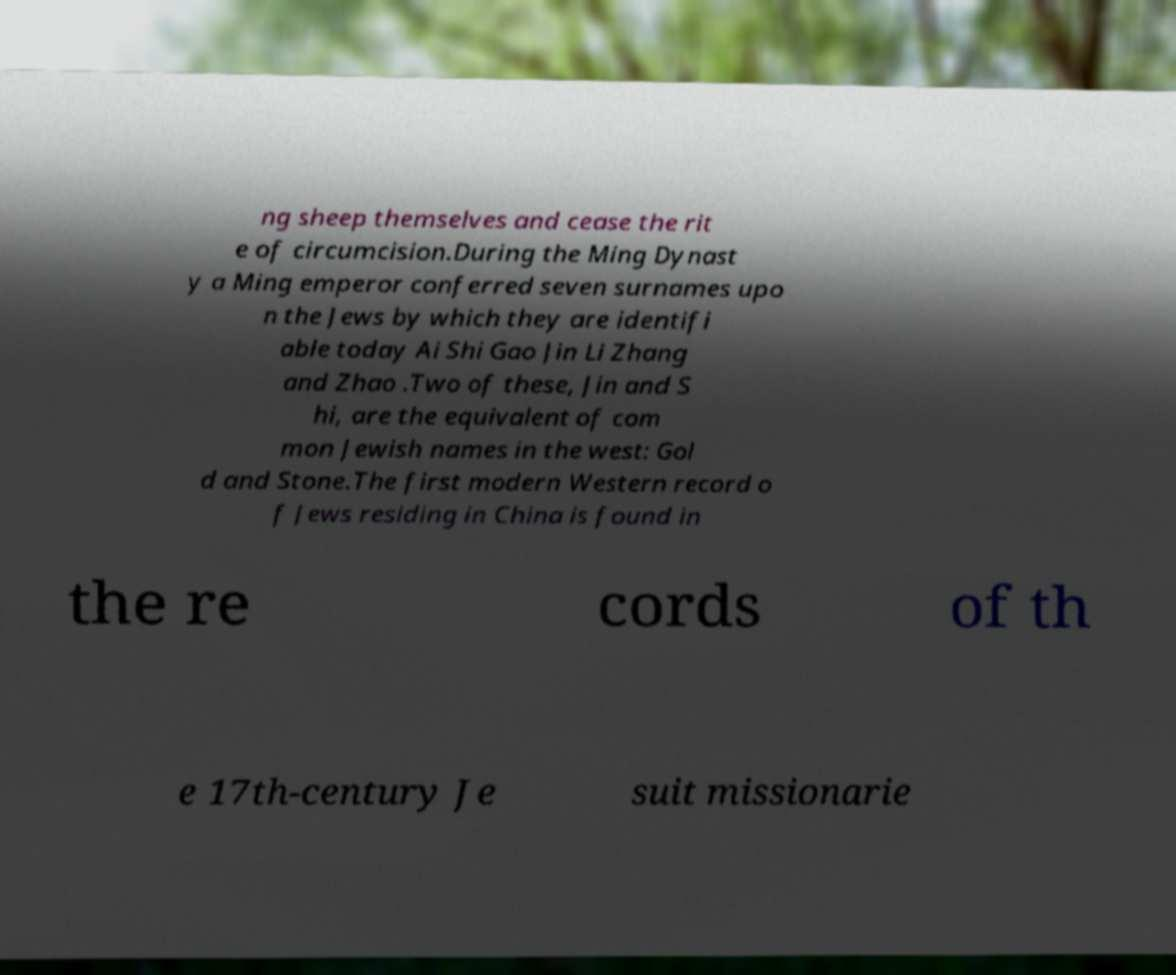There's text embedded in this image that I need extracted. Can you transcribe it verbatim? ng sheep themselves and cease the rit e of circumcision.During the Ming Dynast y a Ming emperor conferred seven surnames upo n the Jews by which they are identifi able today Ai Shi Gao Jin Li Zhang and Zhao .Two of these, Jin and S hi, are the equivalent of com mon Jewish names in the west: Gol d and Stone.The first modern Western record o f Jews residing in China is found in the re cords of th e 17th-century Je suit missionarie 